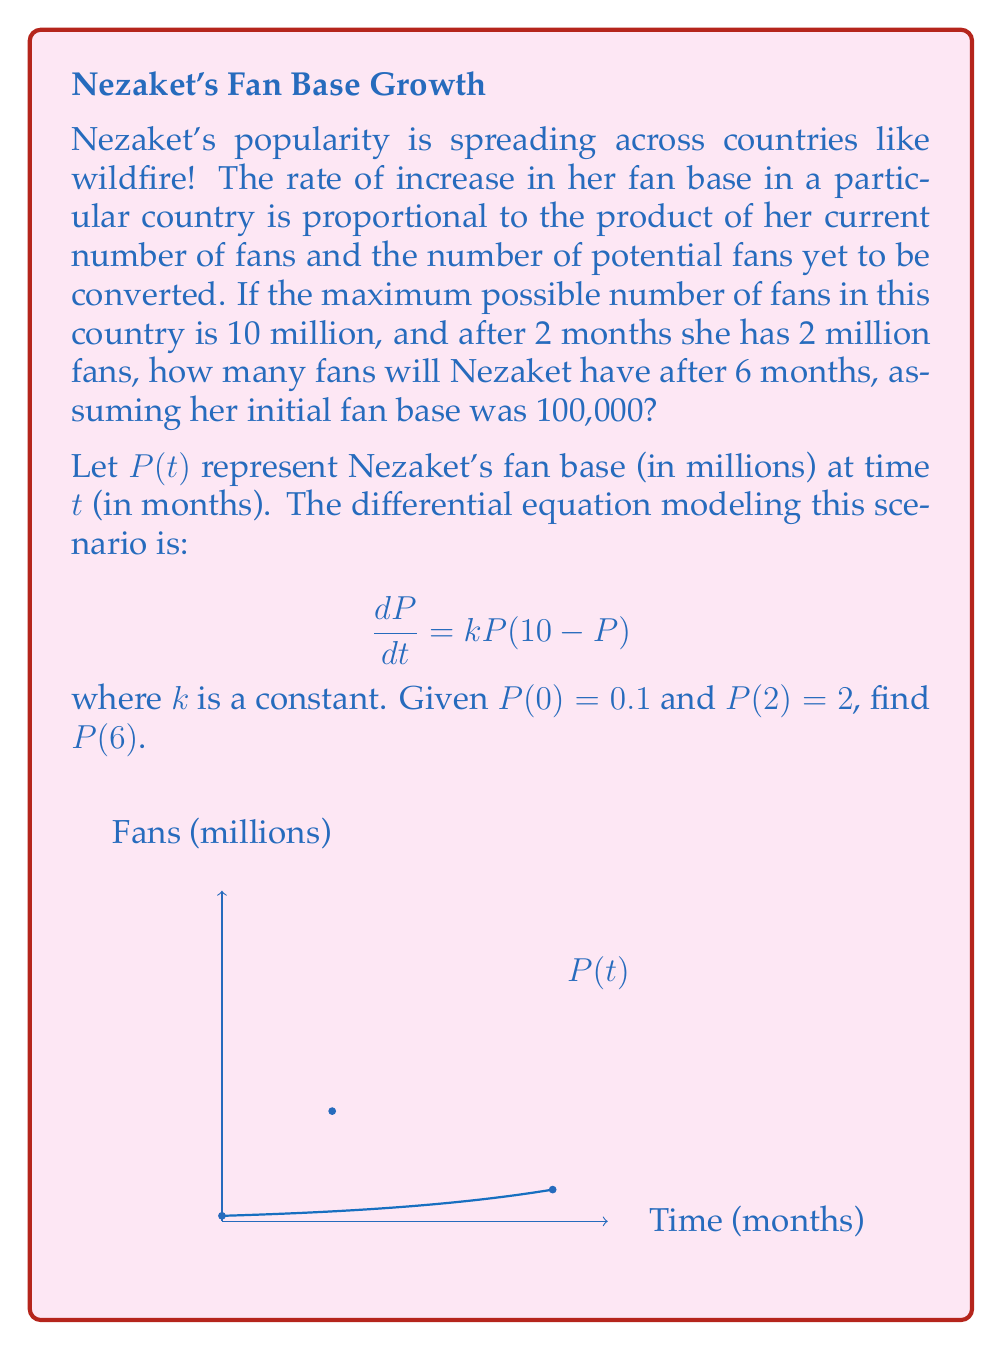Can you answer this question? 1) The given differential equation is a logistic growth model:

   $$\frac{dP}{dt} = kP(10-P)$$

2) The solution to this equation is:

   $$P(t) = \frac{10}{1 + Ce^{-10kt}}$$

   where $C$ is a constant to be determined.

3) Using the initial condition $P(0) = 0.1$:

   $$0.1 = \frac{10}{1 + C} \implies C = 99$$

4) Now we can use $P(2) = 2$ to find $k$:

   $$2 = \frac{10}{1 + 99e^{-20k}}$$

5) Solving for $k$:

   $$99e^{-20k} = 4 \implies k = \frac{\ln(24.75)}{20} \approx 0.16$$

6) Now we have the complete equation:

   $$P(t) = \frac{10}{1 + 99e^{-1.6t}}$$

7) To find $P(6)$, we simply plug in $t = 6$:

   $$P(6) = \frac{10}{1 + 99e^{-1.6(6)}} \approx 7.35$$
Answer: $P(6) \approx 7.35$ million fans 